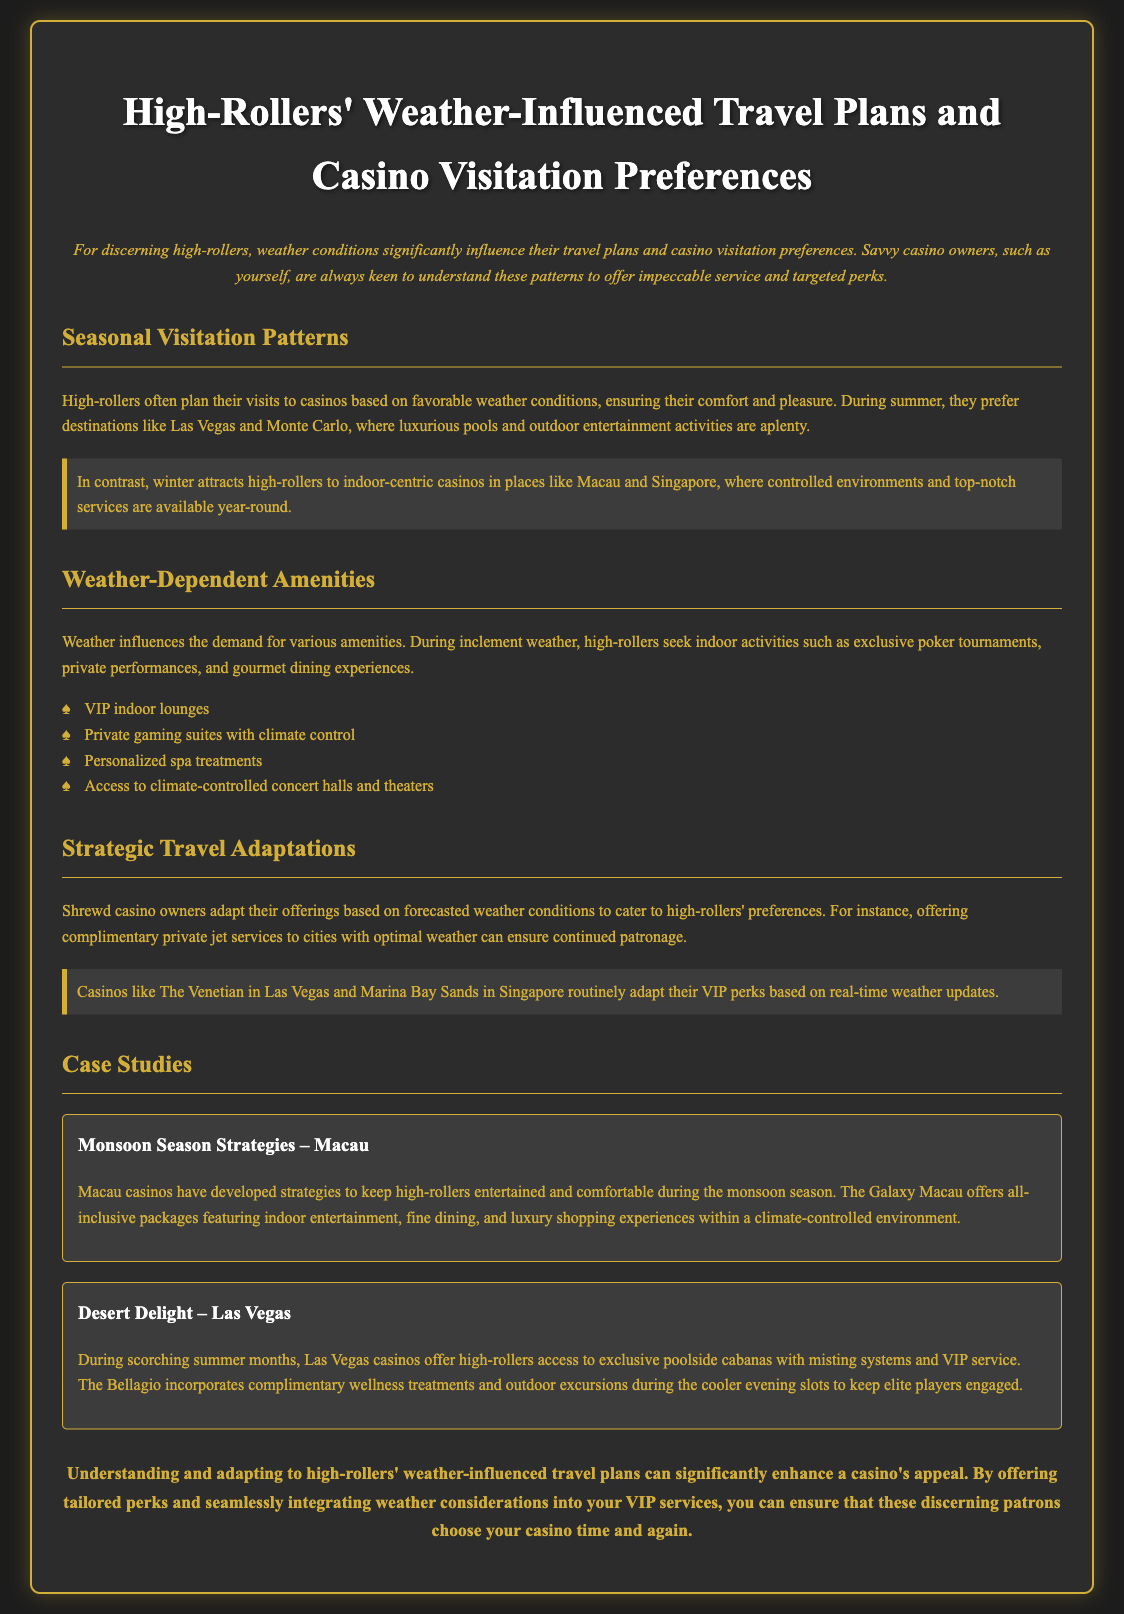What destinations do high-rollers prefer in summer? High-rollers prefer destinations like Las Vegas and Monte Carlo during summer.
Answer: Las Vegas and Monte Carlo What indoor-centric casinos attract high-rollers in winter? Indoor-centric casinos in places like Macau and Singapore attract high-rollers during winter.
Answer: Macau and Singapore What type of amenities do high-rollers seek during inclement weather? High-rollers seek indoor activities such as exclusive poker tournaments, private performances, and gourmet dining experiences during inclement weather.
Answer: Indoor activities What strategy do casino owners employ based on weather forecasts? Casino owners offer complimentary private jet services to cities with optimal weather based on forecasts.
Answer: Complimentary private jet services What special feature is offered to high-rollers in Las Vegas during the summer? Las Vegas casinos offer access to exclusive poolside cabanas with misting systems and VIP service during the summer.
Answer: Exclusive poolside cabanas What does Galaxy Macau provide during the monsoon season? Galaxy Macau offers all-inclusive packages featuring indoor entertainment, fine dining, and luxury shopping experiences during the monsoon season.
Answer: All-inclusive packages Which casino regularly adapts VIP perks based on weather updates? Casinos like The Venetian in Las Vegas and Marina Bay Sands in Singapore routinely adapt their VIP perks based on real-time weather updates.
Answer: The Venetian and Marina Bay Sands What is emphasized for high-rollers on cooler evenings in Las Vegas? The Bellagio incorporates complimentary wellness treatments and outdoor excursions during cooler evening slots to keep elite players engaged.
Answer: Complimentary wellness treatments What conclusion is drawn about high-rollers' travel plans? Understanding and adapting to high-rollers' weather-influenced travel plans can significantly enhance a casino's appeal.
Answer: Enhance a casino's appeal 